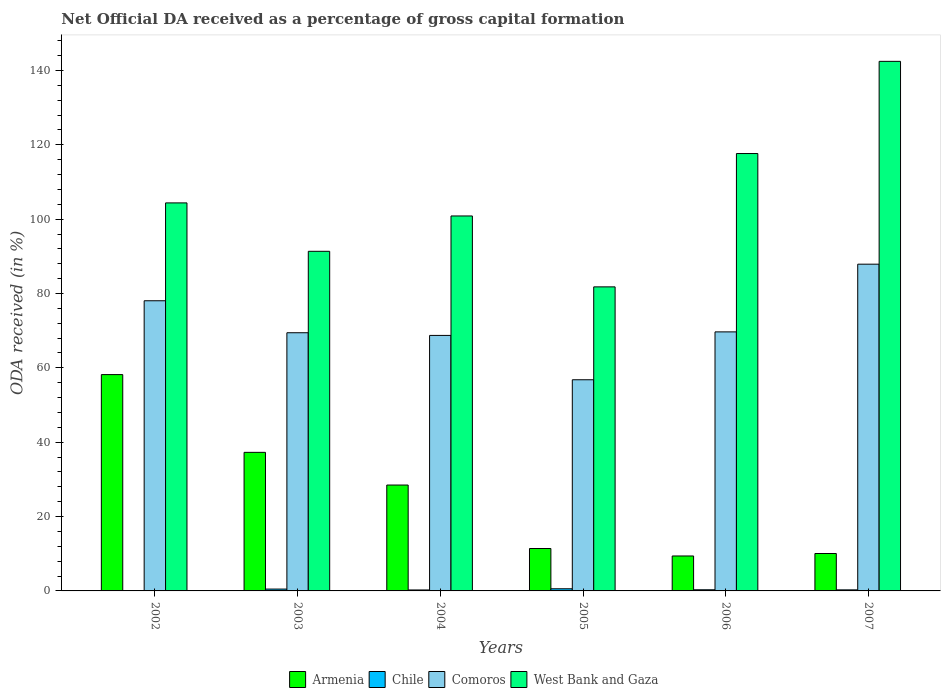Are the number of bars per tick equal to the number of legend labels?
Your response must be concise. No. Are the number of bars on each tick of the X-axis equal?
Ensure brevity in your answer.  No. How many bars are there on the 1st tick from the left?
Provide a succinct answer. 3. How many bars are there on the 6th tick from the right?
Ensure brevity in your answer.  3. What is the label of the 4th group of bars from the left?
Offer a terse response. 2005. In how many cases, is the number of bars for a given year not equal to the number of legend labels?
Your answer should be very brief. 1. What is the net ODA received in Comoros in 2007?
Give a very brief answer. 87.89. Across all years, what is the maximum net ODA received in Armenia?
Your answer should be compact. 58.19. In which year was the net ODA received in Comoros maximum?
Offer a very short reply. 2007. What is the total net ODA received in Comoros in the graph?
Provide a succinct answer. 430.58. What is the difference between the net ODA received in Comoros in 2003 and that in 2004?
Make the answer very short. 0.72. What is the difference between the net ODA received in Comoros in 2005 and the net ODA received in Chile in 2002?
Keep it short and to the point. 56.8. What is the average net ODA received in Chile per year?
Your answer should be very brief. 0.32. In the year 2005, what is the difference between the net ODA received in West Bank and Gaza and net ODA received in Comoros?
Make the answer very short. 24.99. What is the ratio of the net ODA received in Armenia in 2003 to that in 2006?
Provide a short and direct response. 3.96. Is the net ODA received in Comoros in 2004 less than that in 2006?
Make the answer very short. Yes. What is the difference between the highest and the second highest net ODA received in Comoros?
Make the answer very short. 9.84. What is the difference between the highest and the lowest net ODA received in Comoros?
Offer a terse response. 31.09. Is the sum of the net ODA received in Chile in 2004 and 2005 greater than the maximum net ODA received in West Bank and Gaza across all years?
Your answer should be very brief. No. Is it the case that in every year, the sum of the net ODA received in Armenia and net ODA received in West Bank and Gaza is greater than the sum of net ODA received in Comoros and net ODA received in Chile?
Keep it short and to the point. No. Is it the case that in every year, the sum of the net ODA received in Armenia and net ODA received in Comoros is greater than the net ODA received in Chile?
Provide a short and direct response. Yes. How many bars are there?
Keep it short and to the point. 23. Are all the bars in the graph horizontal?
Your answer should be very brief. No. Are the values on the major ticks of Y-axis written in scientific E-notation?
Your answer should be very brief. No. How are the legend labels stacked?
Keep it short and to the point. Horizontal. What is the title of the graph?
Keep it short and to the point. Net Official DA received as a percentage of gross capital formation. What is the label or title of the Y-axis?
Give a very brief answer. ODA received (in %). What is the ODA received (in %) of Armenia in 2002?
Your answer should be compact. 58.19. What is the ODA received (in %) of Chile in 2002?
Your response must be concise. 0. What is the ODA received (in %) of Comoros in 2002?
Your answer should be compact. 78.05. What is the ODA received (in %) of West Bank and Gaza in 2002?
Your answer should be very brief. 104.37. What is the ODA received (in %) in Armenia in 2003?
Your response must be concise. 37.27. What is the ODA received (in %) in Chile in 2003?
Provide a short and direct response. 0.5. What is the ODA received (in %) in Comoros in 2003?
Keep it short and to the point. 69.45. What is the ODA received (in %) of West Bank and Gaza in 2003?
Provide a short and direct response. 91.35. What is the ODA received (in %) of Armenia in 2004?
Your answer should be compact. 28.48. What is the ODA received (in %) of Chile in 2004?
Provide a short and direct response. 0.26. What is the ODA received (in %) of Comoros in 2004?
Make the answer very short. 68.73. What is the ODA received (in %) in West Bank and Gaza in 2004?
Offer a terse response. 100.86. What is the ODA received (in %) in Armenia in 2005?
Provide a succinct answer. 11.41. What is the ODA received (in %) in Chile in 2005?
Provide a short and direct response. 0.58. What is the ODA received (in %) in Comoros in 2005?
Offer a very short reply. 56.8. What is the ODA received (in %) of West Bank and Gaza in 2005?
Offer a terse response. 81.78. What is the ODA received (in %) of Armenia in 2006?
Provide a succinct answer. 9.4. What is the ODA received (in %) of Chile in 2006?
Your answer should be compact. 0.31. What is the ODA received (in %) in Comoros in 2006?
Offer a terse response. 69.68. What is the ODA received (in %) of West Bank and Gaza in 2006?
Your response must be concise. 117.65. What is the ODA received (in %) in Armenia in 2007?
Offer a terse response. 10.06. What is the ODA received (in %) in Chile in 2007?
Your answer should be very brief. 0.29. What is the ODA received (in %) of Comoros in 2007?
Ensure brevity in your answer.  87.89. What is the ODA received (in %) of West Bank and Gaza in 2007?
Ensure brevity in your answer.  142.44. Across all years, what is the maximum ODA received (in %) of Armenia?
Offer a terse response. 58.19. Across all years, what is the maximum ODA received (in %) of Chile?
Offer a terse response. 0.58. Across all years, what is the maximum ODA received (in %) of Comoros?
Ensure brevity in your answer.  87.89. Across all years, what is the maximum ODA received (in %) in West Bank and Gaza?
Make the answer very short. 142.44. Across all years, what is the minimum ODA received (in %) in Armenia?
Your answer should be very brief. 9.4. Across all years, what is the minimum ODA received (in %) of Chile?
Provide a short and direct response. 0. Across all years, what is the minimum ODA received (in %) in Comoros?
Make the answer very short. 56.8. Across all years, what is the minimum ODA received (in %) of West Bank and Gaza?
Your answer should be compact. 81.78. What is the total ODA received (in %) of Armenia in the graph?
Make the answer very short. 154.81. What is the total ODA received (in %) in Chile in the graph?
Keep it short and to the point. 1.93. What is the total ODA received (in %) in Comoros in the graph?
Make the answer very short. 430.58. What is the total ODA received (in %) of West Bank and Gaza in the graph?
Provide a succinct answer. 638.45. What is the difference between the ODA received (in %) of Armenia in 2002 and that in 2003?
Offer a very short reply. 20.91. What is the difference between the ODA received (in %) of Comoros in 2002 and that in 2003?
Ensure brevity in your answer.  8.6. What is the difference between the ODA received (in %) in West Bank and Gaza in 2002 and that in 2003?
Keep it short and to the point. 13.02. What is the difference between the ODA received (in %) in Armenia in 2002 and that in 2004?
Ensure brevity in your answer.  29.71. What is the difference between the ODA received (in %) in Comoros in 2002 and that in 2004?
Provide a short and direct response. 9.32. What is the difference between the ODA received (in %) of West Bank and Gaza in 2002 and that in 2004?
Keep it short and to the point. 3.51. What is the difference between the ODA received (in %) in Armenia in 2002 and that in 2005?
Make the answer very short. 46.78. What is the difference between the ODA received (in %) of Comoros in 2002 and that in 2005?
Offer a very short reply. 21.25. What is the difference between the ODA received (in %) in West Bank and Gaza in 2002 and that in 2005?
Your response must be concise. 22.59. What is the difference between the ODA received (in %) of Armenia in 2002 and that in 2006?
Your response must be concise. 48.78. What is the difference between the ODA received (in %) in Comoros in 2002 and that in 2006?
Keep it short and to the point. 8.37. What is the difference between the ODA received (in %) of West Bank and Gaza in 2002 and that in 2006?
Ensure brevity in your answer.  -13.28. What is the difference between the ODA received (in %) of Armenia in 2002 and that in 2007?
Your answer should be very brief. 48.12. What is the difference between the ODA received (in %) of Comoros in 2002 and that in 2007?
Offer a terse response. -9.84. What is the difference between the ODA received (in %) in West Bank and Gaza in 2002 and that in 2007?
Provide a succinct answer. -38.08. What is the difference between the ODA received (in %) in Armenia in 2003 and that in 2004?
Ensure brevity in your answer.  8.79. What is the difference between the ODA received (in %) of Chile in 2003 and that in 2004?
Your response must be concise. 0.24. What is the difference between the ODA received (in %) of Comoros in 2003 and that in 2004?
Give a very brief answer. 0.72. What is the difference between the ODA received (in %) of West Bank and Gaza in 2003 and that in 2004?
Offer a very short reply. -9.51. What is the difference between the ODA received (in %) in Armenia in 2003 and that in 2005?
Offer a terse response. 25.86. What is the difference between the ODA received (in %) of Chile in 2003 and that in 2005?
Ensure brevity in your answer.  -0.08. What is the difference between the ODA received (in %) of Comoros in 2003 and that in 2005?
Offer a very short reply. 12.65. What is the difference between the ODA received (in %) in West Bank and Gaza in 2003 and that in 2005?
Your answer should be very brief. 9.57. What is the difference between the ODA received (in %) in Armenia in 2003 and that in 2006?
Provide a succinct answer. 27.87. What is the difference between the ODA received (in %) in Chile in 2003 and that in 2006?
Ensure brevity in your answer.  0.19. What is the difference between the ODA received (in %) in Comoros in 2003 and that in 2006?
Your response must be concise. -0.23. What is the difference between the ODA received (in %) in West Bank and Gaza in 2003 and that in 2006?
Give a very brief answer. -26.3. What is the difference between the ODA received (in %) of Armenia in 2003 and that in 2007?
Offer a very short reply. 27.21. What is the difference between the ODA received (in %) in Chile in 2003 and that in 2007?
Ensure brevity in your answer.  0.21. What is the difference between the ODA received (in %) in Comoros in 2003 and that in 2007?
Keep it short and to the point. -18.44. What is the difference between the ODA received (in %) of West Bank and Gaza in 2003 and that in 2007?
Give a very brief answer. -51.09. What is the difference between the ODA received (in %) of Armenia in 2004 and that in 2005?
Make the answer very short. 17.07. What is the difference between the ODA received (in %) of Chile in 2004 and that in 2005?
Ensure brevity in your answer.  -0.32. What is the difference between the ODA received (in %) in Comoros in 2004 and that in 2005?
Your response must be concise. 11.93. What is the difference between the ODA received (in %) in West Bank and Gaza in 2004 and that in 2005?
Provide a short and direct response. 19.07. What is the difference between the ODA received (in %) in Armenia in 2004 and that in 2006?
Provide a short and direct response. 19.08. What is the difference between the ODA received (in %) in Chile in 2004 and that in 2006?
Give a very brief answer. -0.05. What is the difference between the ODA received (in %) in Comoros in 2004 and that in 2006?
Your response must be concise. -0.95. What is the difference between the ODA received (in %) in West Bank and Gaza in 2004 and that in 2006?
Give a very brief answer. -16.79. What is the difference between the ODA received (in %) in Armenia in 2004 and that in 2007?
Provide a short and direct response. 18.42. What is the difference between the ODA received (in %) of Chile in 2004 and that in 2007?
Give a very brief answer. -0.03. What is the difference between the ODA received (in %) of Comoros in 2004 and that in 2007?
Ensure brevity in your answer.  -19.16. What is the difference between the ODA received (in %) of West Bank and Gaza in 2004 and that in 2007?
Offer a very short reply. -41.59. What is the difference between the ODA received (in %) of Armenia in 2005 and that in 2006?
Make the answer very short. 2.01. What is the difference between the ODA received (in %) of Chile in 2005 and that in 2006?
Your answer should be very brief. 0.27. What is the difference between the ODA received (in %) in Comoros in 2005 and that in 2006?
Your answer should be compact. -12.88. What is the difference between the ODA received (in %) of West Bank and Gaza in 2005 and that in 2006?
Keep it short and to the point. -35.87. What is the difference between the ODA received (in %) of Armenia in 2005 and that in 2007?
Offer a very short reply. 1.35. What is the difference between the ODA received (in %) of Chile in 2005 and that in 2007?
Your answer should be compact. 0.29. What is the difference between the ODA received (in %) of Comoros in 2005 and that in 2007?
Your answer should be compact. -31.09. What is the difference between the ODA received (in %) of West Bank and Gaza in 2005 and that in 2007?
Ensure brevity in your answer.  -60.66. What is the difference between the ODA received (in %) of Armenia in 2006 and that in 2007?
Provide a succinct answer. -0.66. What is the difference between the ODA received (in %) of Chile in 2006 and that in 2007?
Offer a terse response. 0.03. What is the difference between the ODA received (in %) of Comoros in 2006 and that in 2007?
Make the answer very short. -18.21. What is the difference between the ODA received (in %) in West Bank and Gaza in 2006 and that in 2007?
Offer a very short reply. -24.8. What is the difference between the ODA received (in %) in Armenia in 2002 and the ODA received (in %) in Chile in 2003?
Offer a terse response. 57.69. What is the difference between the ODA received (in %) in Armenia in 2002 and the ODA received (in %) in Comoros in 2003?
Offer a terse response. -11.26. What is the difference between the ODA received (in %) in Armenia in 2002 and the ODA received (in %) in West Bank and Gaza in 2003?
Keep it short and to the point. -33.16. What is the difference between the ODA received (in %) in Comoros in 2002 and the ODA received (in %) in West Bank and Gaza in 2003?
Ensure brevity in your answer.  -13.3. What is the difference between the ODA received (in %) of Armenia in 2002 and the ODA received (in %) of Chile in 2004?
Give a very brief answer. 57.93. What is the difference between the ODA received (in %) in Armenia in 2002 and the ODA received (in %) in Comoros in 2004?
Provide a succinct answer. -10.54. What is the difference between the ODA received (in %) of Armenia in 2002 and the ODA received (in %) of West Bank and Gaza in 2004?
Your response must be concise. -42.67. What is the difference between the ODA received (in %) in Comoros in 2002 and the ODA received (in %) in West Bank and Gaza in 2004?
Your answer should be very brief. -22.81. What is the difference between the ODA received (in %) of Armenia in 2002 and the ODA received (in %) of Chile in 2005?
Your answer should be very brief. 57.61. What is the difference between the ODA received (in %) in Armenia in 2002 and the ODA received (in %) in Comoros in 2005?
Provide a short and direct response. 1.39. What is the difference between the ODA received (in %) in Armenia in 2002 and the ODA received (in %) in West Bank and Gaza in 2005?
Keep it short and to the point. -23.6. What is the difference between the ODA received (in %) in Comoros in 2002 and the ODA received (in %) in West Bank and Gaza in 2005?
Keep it short and to the point. -3.73. What is the difference between the ODA received (in %) in Armenia in 2002 and the ODA received (in %) in Chile in 2006?
Ensure brevity in your answer.  57.88. What is the difference between the ODA received (in %) in Armenia in 2002 and the ODA received (in %) in Comoros in 2006?
Your answer should be very brief. -11.49. What is the difference between the ODA received (in %) of Armenia in 2002 and the ODA received (in %) of West Bank and Gaza in 2006?
Offer a terse response. -59.46. What is the difference between the ODA received (in %) of Comoros in 2002 and the ODA received (in %) of West Bank and Gaza in 2006?
Ensure brevity in your answer.  -39.6. What is the difference between the ODA received (in %) of Armenia in 2002 and the ODA received (in %) of Chile in 2007?
Provide a succinct answer. 57.9. What is the difference between the ODA received (in %) in Armenia in 2002 and the ODA received (in %) in Comoros in 2007?
Make the answer very short. -29.7. What is the difference between the ODA received (in %) of Armenia in 2002 and the ODA received (in %) of West Bank and Gaza in 2007?
Ensure brevity in your answer.  -84.26. What is the difference between the ODA received (in %) in Comoros in 2002 and the ODA received (in %) in West Bank and Gaza in 2007?
Offer a very short reply. -64.4. What is the difference between the ODA received (in %) of Armenia in 2003 and the ODA received (in %) of Chile in 2004?
Provide a short and direct response. 37.01. What is the difference between the ODA received (in %) in Armenia in 2003 and the ODA received (in %) in Comoros in 2004?
Provide a short and direct response. -31.45. What is the difference between the ODA received (in %) of Armenia in 2003 and the ODA received (in %) of West Bank and Gaza in 2004?
Your answer should be very brief. -63.58. What is the difference between the ODA received (in %) in Chile in 2003 and the ODA received (in %) in Comoros in 2004?
Your answer should be compact. -68.23. What is the difference between the ODA received (in %) of Chile in 2003 and the ODA received (in %) of West Bank and Gaza in 2004?
Offer a very short reply. -100.36. What is the difference between the ODA received (in %) in Comoros in 2003 and the ODA received (in %) in West Bank and Gaza in 2004?
Give a very brief answer. -31.41. What is the difference between the ODA received (in %) of Armenia in 2003 and the ODA received (in %) of Chile in 2005?
Keep it short and to the point. 36.69. What is the difference between the ODA received (in %) in Armenia in 2003 and the ODA received (in %) in Comoros in 2005?
Ensure brevity in your answer.  -19.53. What is the difference between the ODA received (in %) in Armenia in 2003 and the ODA received (in %) in West Bank and Gaza in 2005?
Provide a succinct answer. -44.51. What is the difference between the ODA received (in %) in Chile in 2003 and the ODA received (in %) in Comoros in 2005?
Make the answer very short. -56.3. What is the difference between the ODA received (in %) in Chile in 2003 and the ODA received (in %) in West Bank and Gaza in 2005?
Give a very brief answer. -81.29. What is the difference between the ODA received (in %) in Comoros in 2003 and the ODA received (in %) in West Bank and Gaza in 2005?
Make the answer very short. -12.34. What is the difference between the ODA received (in %) of Armenia in 2003 and the ODA received (in %) of Chile in 2006?
Your answer should be very brief. 36.96. What is the difference between the ODA received (in %) of Armenia in 2003 and the ODA received (in %) of Comoros in 2006?
Offer a very short reply. -32.41. What is the difference between the ODA received (in %) in Armenia in 2003 and the ODA received (in %) in West Bank and Gaza in 2006?
Your answer should be compact. -80.38. What is the difference between the ODA received (in %) of Chile in 2003 and the ODA received (in %) of Comoros in 2006?
Your response must be concise. -69.18. What is the difference between the ODA received (in %) of Chile in 2003 and the ODA received (in %) of West Bank and Gaza in 2006?
Keep it short and to the point. -117.15. What is the difference between the ODA received (in %) in Comoros in 2003 and the ODA received (in %) in West Bank and Gaza in 2006?
Provide a succinct answer. -48.2. What is the difference between the ODA received (in %) in Armenia in 2003 and the ODA received (in %) in Chile in 2007?
Provide a succinct answer. 36.99. What is the difference between the ODA received (in %) of Armenia in 2003 and the ODA received (in %) of Comoros in 2007?
Provide a short and direct response. -50.61. What is the difference between the ODA received (in %) in Armenia in 2003 and the ODA received (in %) in West Bank and Gaza in 2007?
Offer a terse response. -105.17. What is the difference between the ODA received (in %) in Chile in 2003 and the ODA received (in %) in Comoros in 2007?
Provide a succinct answer. -87.39. What is the difference between the ODA received (in %) of Chile in 2003 and the ODA received (in %) of West Bank and Gaza in 2007?
Ensure brevity in your answer.  -141.95. What is the difference between the ODA received (in %) in Comoros in 2003 and the ODA received (in %) in West Bank and Gaza in 2007?
Give a very brief answer. -73. What is the difference between the ODA received (in %) of Armenia in 2004 and the ODA received (in %) of Chile in 2005?
Provide a short and direct response. 27.9. What is the difference between the ODA received (in %) in Armenia in 2004 and the ODA received (in %) in Comoros in 2005?
Ensure brevity in your answer.  -28.32. What is the difference between the ODA received (in %) of Armenia in 2004 and the ODA received (in %) of West Bank and Gaza in 2005?
Offer a very short reply. -53.31. What is the difference between the ODA received (in %) in Chile in 2004 and the ODA received (in %) in Comoros in 2005?
Provide a short and direct response. -56.54. What is the difference between the ODA received (in %) of Chile in 2004 and the ODA received (in %) of West Bank and Gaza in 2005?
Your response must be concise. -81.53. What is the difference between the ODA received (in %) in Comoros in 2004 and the ODA received (in %) in West Bank and Gaza in 2005?
Ensure brevity in your answer.  -13.06. What is the difference between the ODA received (in %) of Armenia in 2004 and the ODA received (in %) of Chile in 2006?
Provide a succinct answer. 28.17. What is the difference between the ODA received (in %) in Armenia in 2004 and the ODA received (in %) in Comoros in 2006?
Ensure brevity in your answer.  -41.2. What is the difference between the ODA received (in %) of Armenia in 2004 and the ODA received (in %) of West Bank and Gaza in 2006?
Keep it short and to the point. -89.17. What is the difference between the ODA received (in %) of Chile in 2004 and the ODA received (in %) of Comoros in 2006?
Your answer should be compact. -69.42. What is the difference between the ODA received (in %) of Chile in 2004 and the ODA received (in %) of West Bank and Gaza in 2006?
Provide a short and direct response. -117.39. What is the difference between the ODA received (in %) in Comoros in 2004 and the ODA received (in %) in West Bank and Gaza in 2006?
Your answer should be compact. -48.92. What is the difference between the ODA received (in %) of Armenia in 2004 and the ODA received (in %) of Chile in 2007?
Your response must be concise. 28.19. What is the difference between the ODA received (in %) of Armenia in 2004 and the ODA received (in %) of Comoros in 2007?
Keep it short and to the point. -59.41. What is the difference between the ODA received (in %) of Armenia in 2004 and the ODA received (in %) of West Bank and Gaza in 2007?
Offer a very short reply. -113.97. What is the difference between the ODA received (in %) in Chile in 2004 and the ODA received (in %) in Comoros in 2007?
Provide a short and direct response. -87.63. What is the difference between the ODA received (in %) in Chile in 2004 and the ODA received (in %) in West Bank and Gaza in 2007?
Make the answer very short. -142.19. What is the difference between the ODA received (in %) of Comoros in 2004 and the ODA received (in %) of West Bank and Gaza in 2007?
Offer a very short reply. -73.72. What is the difference between the ODA received (in %) of Armenia in 2005 and the ODA received (in %) of Chile in 2006?
Your response must be concise. 11.1. What is the difference between the ODA received (in %) in Armenia in 2005 and the ODA received (in %) in Comoros in 2006?
Ensure brevity in your answer.  -58.27. What is the difference between the ODA received (in %) in Armenia in 2005 and the ODA received (in %) in West Bank and Gaza in 2006?
Provide a short and direct response. -106.24. What is the difference between the ODA received (in %) of Chile in 2005 and the ODA received (in %) of Comoros in 2006?
Offer a very short reply. -69.1. What is the difference between the ODA received (in %) of Chile in 2005 and the ODA received (in %) of West Bank and Gaza in 2006?
Offer a very short reply. -117.07. What is the difference between the ODA received (in %) in Comoros in 2005 and the ODA received (in %) in West Bank and Gaza in 2006?
Provide a short and direct response. -60.85. What is the difference between the ODA received (in %) in Armenia in 2005 and the ODA received (in %) in Chile in 2007?
Your answer should be compact. 11.12. What is the difference between the ODA received (in %) of Armenia in 2005 and the ODA received (in %) of Comoros in 2007?
Provide a short and direct response. -76.48. What is the difference between the ODA received (in %) in Armenia in 2005 and the ODA received (in %) in West Bank and Gaza in 2007?
Make the answer very short. -131.04. What is the difference between the ODA received (in %) of Chile in 2005 and the ODA received (in %) of Comoros in 2007?
Your response must be concise. -87.31. What is the difference between the ODA received (in %) in Chile in 2005 and the ODA received (in %) in West Bank and Gaza in 2007?
Your response must be concise. -141.87. What is the difference between the ODA received (in %) of Comoros in 2005 and the ODA received (in %) of West Bank and Gaza in 2007?
Your response must be concise. -85.65. What is the difference between the ODA received (in %) in Armenia in 2006 and the ODA received (in %) in Chile in 2007?
Keep it short and to the point. 9.12. What is the difference between the ODA received (in %) in Armenia in 2006 and the ODA received (in %) in Comoros in 2007?
Provide a succinct answer. -78.48. What is the difference between the ODA received (in %) in Armenia in 2006 and the ODA received (in %) in West Bank and Gaza in 2007?
Your answer should be compact. -133.04. What is the difference between the ODA received (in %) of Chile in 2006 and the ODA received (in %) of Comoros in 2007?
Offer a terse response. -87.58. What is the difference between the ODA received (in %) in Chile in 2006 and the ODA received (in %) in West Bank and Gaza in 2007?
Offer a terse response. -142.13. What is the difference between the ODA received (in %) of Comoros in 2006 and the ODA received (in %) of West Bank and Gaza in 2007?
Keep it short and to the point. -72.77. What is the average ODA received (in %) in Armenia per year?
Keep it short and to the point. 25.8. What is the average ODA received (in %) of Chile per year?
Your answer should be compact. 0.32. What is the average ODA received (in %) of Comoros per year?
Your answer should be compact. 71.76. What is the average ODA received (in %) in West Bank and Gaza per year?
Offer a very short reply. 106.41. In the year 2002, what is the difference between the ODA received (in %) of Armenia and ODA received (in %) of Comoros?
Make the answer very short. -19.86. In the year 2002, what is the difference between the ODA received (in %) in Armenia and ODA received (in %) in West Bank and Gaza?
Ensure brevity in your answer.  -46.18. In the year 2002, what is the difference between the ODA received (in %) in Comoros and ODA received (in %) in West Bank and Gaza?
Ensure brevity in your answer.  -26.32. In the year 2003, what is the difference between the ODA received (in %) of Armenia and ODA received (in %) of Chile?
Provide a succinct answer. 36.77. In the year 2003, what is the difference between the ODA received (in %) of Armenia and ODA received (in %) of Comoros?
Give a very brief answer. -32.17. In the year 2003, what is the difference between the ODA received (in %) in Armenia and ODA received (in %) in West Bank and Gaza?
Keep it short and to the point. -54.08. In the year 2003, what is the difference between the ODA received (in %) of Chile and ODA received (in %) of Comoros?
Your answer should be compact. -68.95. In the year 2003, what is the difference between the ODA received (in %) in Chile and ODA received (in %) in West Bank and Gaza?
Give a very brief answer. -90.85. In the year 2003, what is the difference between the ODA received (in %) in Comoros and ODA received (in %) in West Bank and Gaza?
Your answer should be very brief. -21.91. In the year 2004, what is the difference between the ODA received (in %) in Armenia and ODA received (in %) in Chile?
Offer a very short reply. 28.22. In the year 2004, what is the difference between the ODA received (in %) of Armenia and ODA received (in %) of Comoros?
Offer a very short reply. -40.25. In the year 2004, what is the difference between the ODA received (in %) in Armenia and ODA received (in %) in West Bank and Gaza?
Your response must be concise. -72.38. In the year 2004, what is the difference between the ODA received (in %) in Chile and ODA received (in %) in Comoros?
Make the answer very short. -68.47. In the year 2004, what is the difference between the ODA received (in %) of Chile and ODA received (in %) of West Bank and Gaza?
Offer a very short reply. -100.6. In the year 2004, what is the difference between the ODA received (in %) in Comoros and ODA received (in %) in West Bank and Gaza?
Give a very brief answer. -32.13. In the year 2005, what is the difference between the ODA received (in %) in Armenia and ODA received (in %) in Chile?
Your answer should be very brief. 10.83. In the year 2005, what is the difference between the ODA received (in %) of Armenia and ODA received (in %) of Comoros?
Your answer should be compact. -45.39. In the year 2005, what is the difference between the ODA received (in %) of Armenia and ODA received (in %) of West Bank and Gaza?
Give a very brief answer. -70.38. In the year 2005, what is the difference between the ODA received (in %) in Chile and ODA received (in %) in Comoros?
Provide a succinct answer. -56.22. In the year 2005, what is the difference between the ODA received (in %) in Chile and ODA received (in %) in West Bank and Gaza?
Your response must be concise. -81.21. In the year 2005, what is the difference between the ODA received (in %) in Comoros and ODA received (in %) in West Bank and Gaza?
Your response must be concise. -24.99. In the year 2006, what is the difference between the ODA received (in %) of Armenia and ODA received (in %) of Chile?
Offer a terse response. 9.09. In the year 2006, what is the difference between the ODA received (in %) in Armenia and ODA received (in %) in Comoros?
Your response must be concise. -60.28. In the year 2006, what is the difference between the ODA received (in %) in Armenia and ODA received (in %) in West Bank and Gaza?
Provide a succinct answer. -108.25. In the year 2006, what is the difference between the ODA received (in %) of Chile and ODA received (in %) of Comoros?
Ensure brevity in your answer.  -69.37. In the year 2006, what is the difference between the ODA received (in %) of Chile and ODA received (in %) of West Bank and Gaza?
Keep it short and to the point. -117.34. In the year 2006, what is the difference between the ODA received (in %) in Comoros and ODA received (in %) in West Bank and Gaza?
Offer a very short reply. -47.97. In the year 2007, what is the difference between the ODA received (in %) of Armenia and ODA received (in %) of Chile?
Make the answer very short. 9.78. In the year 2007, what is the difference between the ODA received (in %) in Armenia and ODA received (in %) in Comoros?
Ensure brevity in your answer.  -77.82. In the year 2007, what is the difference between the ODA received (in %) of Armenia and ODA received (in %) of West Bank and Gaza?
Provide a short and direct response. -132.38. In the year 2007, what is the difference between the ODA received (in %) of Chile and ODA received (in %) of Comoros?
Your response must be concise. -87.6. In the year 2007, what is the difference between the ODA received (in %) of Chile and ODA received (in %) of West Bank and Gaza?
Your answer should be compact. -142.16. In the year 2007, what is the difference between the ODA received (in %) of Comoros and ODA received (in %) of West Bank and Gaza?
Provide a short and direct response. -54.56. What is the ratio of the ODA received (in %) of Armenia in 2002 to that in 2003?
Your answer should be very brief. 1.56. What is the ratio of the ODA received (in %) in Comoros in 2002 to that in 2003?
Make the answer very short. 1.12. What is the ratio of the ODA received (in %) of West Bank and Gaza in 2002 to that in 2003?
Provide a succinct answer. 1.14. What is the ratio of the ODA received (in %) of Armenia in 2002 to that in 2004?
Provide a succinct answer. 2.04. What is the ratio of the ODA received (in %) of Comoros in 2002 to that in 2004?
Your answer should be very brief. 1.14. What is the ratio of the ODA received (in %) of West Bank and Gaza in 2002 to that in 2004?
Ensure brevity in your answer.  1.03. What is the ratio of the ODA received (in %) in Armenia in 2002 to that in 2005?
Offer a very short reply. 5.1. What is the ratio of the ODA received (in %) of Comoros in 2002 to that in 2005?
Offer a terse response. 1.37. What is the ratio of the ODA received (in %) of West Bank and Gaza in 2002 to that in 2005?
Your response must be concise. 1.28. What is the ratio of the ODA received (in %) in Armenia in 2002 to that in 2006?
Ensure brevity in your answer.  6.19. What is the ratio of the ODA received (in %) of Comoros in 2002 to that in 2006?
Make the answer very short. 1.12. What is the ratio of the ODA received (in %) of West Bank and Gaza in 2002 to that in 2006?
Your answer should be compact. 0.89. What is the ratio of the ODA received (in %) in Armenia in 2002 to that in 2007?
Provide a short and direct response. 5.78. What is the ratio of the ODA received (in %) in Comoros in 2002 to that in 2007?
Your answer should be compact. 0.89. What is the ratio of the ODA received (in %) of West Bank and Gaza in 2002 to that in 2007?
Offer a very short reply. 0.73. What is the ratio of the ODA received (in %) of Armenia in 2003 to that in 2004?
Your response must be concise. 1.31. What is the ratio of the ODA received (in %) in Chile in 2003 to that in 2004?
Your answer should be compact. 1.92. What is the ratio of the ODA received (in %) in Comoros in 2003 to that in 2004?
Your answer should be very brief. 1.01. What is the ratio of the ODA received (in %) of West Bank and Gaza in 2003 to that in 2004?
Make the answer very short. 0.91. What is the ratio of the ODA received (in %) of Armenia in 2003 to that in 2005?
Make the answer very short. 3.27. What is the ratio of the ODA received (in %) of Chile in 2003 to that in 2005?
Offer a terse response. 0.86. What is the ratio of the ODA received (in %) of Comoros in 2003 to that in 2005?
Offer a terse response. 1.22. What is the ratio of the ODA received (in %) in West Bank and Gaza in 2003 to that in 2005?
Ensure brevity in your answer.  1.12. What is the ratio of the ODA received (in %) of Armenia in 2003 to that in 2006?
Keep it short and to the point. 3.96. What is the ratio of the ODA received (in %) in Chile in 2003 to that in 2006?
Your answer should be compact. 1.6. What is the ratio of the ODA received (in %) of West Bank and Gaza in 2003 to that in 2006?
Offer a terse response. 0.78. What is the ratio of the ODA received (in %) of Armenia in 2003 to that in 2007?
Provide a succinct answer. 3.7. What is the ratio of the ODA received (in %) in Chile in 2003 to that in 2007?
Provide a succinct answer. 1.74. What is the ratio of the ODA received (in %) of Comoros in 2003 to that in 2007?
Provide a short and direct response. 0.79. What is the ratio of the ODA received (in %) in West Bank and Gaza in 2003 to that in 2007?
Offer a terse response. 0.64. What is the ratio of the ODA received (in %) of Armenia in 2004 to that in 2005?
Offer a terse response. 2.5. What is the ratio of the ODA received (in %) in Chile in 2004 to that in 2005?
Give a very brief answer. 0.45. What is the ratio of the ODA received (in %) in Comoros in 2004 to that in 2005?
Your response must be concise. 1.21. What is the ratio of the ODA received (in %) in West Bank and Gaza in 2004 to that in 2005?
Give a very brief answer. 1.23. What is the ratio of the ODA received (in %) of Armenia in 2004 to that in 2006?
Your answer should be compact. 3.03. What is the ratio of the ODA received (in %) in Chile in 2004 to that in 2006?
Make the answer very short. 0.83. What is the ratio of the ODA received (in %) of Comoros in 2004 to that in 2006?
Give a very brief answer. 0.99. What is the ratio of the ODA received (in %) of West Bank and Gaza in 2004 to that in 2006?
Make the answer very short. 0.86. What is the ratio of the ODA received (in %) of Armenia in 2004 to that in 2007?
Your answer should be compact. 2.83. What is the ratio of the ODA received (in %) in Chile in 2004 to that in 2007?
Your response must be concise. 0.91. What is the ratio of the ODA received (in %) in Comoros in 2004 to that in 2007?
Make the answer very short. 0.78. What is the ratio of the ODA received (in %) in West Bank and Gaza in 2004 to that in 2007?
Provide a short and direct response. 0.71. What is the ratio of the ODA received (in %) in Armenia in 2005 to that in 2006?
Your response must be concise. 1.21. What is the ratio of the ODA received (in %) of Chile in 2005 to that in 2006?
Offer a very short reply. 1.86. What is the ratio of the ODA received (in %) in Comoros in 2005 to that in 2006?
Make the answer very short. 0.82. What is the ratio of the ODA received (in %) in West Bank and Gaza in 2005 to that in 2006?
Ensure brevity in your answer.  0.7. What is the ratio of the ODA received (in %) in Armenia in 2005 to that in 2007?
Your answer should be compact. 1.13. What is the ratio of the ODA received (in %) of Chile in 2005 to that in 2007?
Keep it short and to the point. 2.02. What is the ratio of the ODA received (in %) of Comoros in 2005 to that in 2007?
Give a very brief answer. 0.65. What is the ratio of the ODA received (in %) in West Bank and Gaza in 2005 to that in 2007?
Your response must be concise. 0.57. What is the ratio of the ODA received (in %) of Armenia in 2006 to that in 2007?
Ensure brevity in your answer.  0.93. What is the ratio of the ODA received (in %) in Chile in 2006 to that in 2007?
Ensure brevity in your answer.  1.09. What is the ratio of the ODA received (in %) in Comoros in 2006 to that in 2007?
Ensure brevity in your answer.  0.79. What is the ratio of the ODA received (in %) of West Bank and Gaza in 2006 to that in 2007?
Make the answer very short. 0.83. What is the difference between the highest and the second highest ODA received (in %) of Armenia?
Keep it short and to the point. 20.91. What is the difference between the highest and the second highest ODA received (in %) in Chile?
Offer a very short reply. 0.08. What is the difference between the highest and the second highest ODA received (in %) of Comoros?
Your answer should be very brief. 9.84. What is the difference between the highest and the second highest ODA received (in %) in West Bank and Gaza?
Ensure brevity in your answer.  24.8. What is the difference between the highest and the lowest ODA received (in %) in Armenia?
Provide a succinct answer. 48.78. What is the difference between the highest and the lowest ODA received (in %) in Chile?
Provide a short and direct response. 0.58. What is the difference between the highest and the lowest ODA received (in %) of Comoros?
Make the answer very short. 31.09. What is the difference between the highest and the lowest ODA received (in %) of West Bank and Gaza?
Keep it short and to the point. 60.66. 